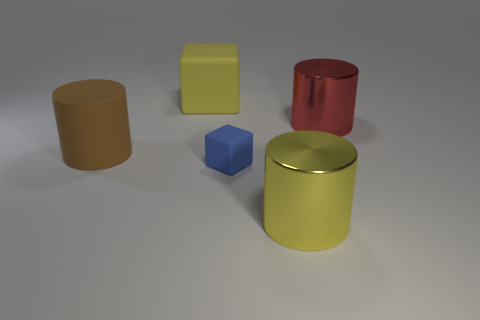What material is the yellow object in front of the large yellow object behind the red object made of? The yellow object in question, which is positioned in front of a larger yellow object that in turn is behind the red object, appears to be made of a plastic material, characterized by its uniform color and matte surface which are common in plastic objects. 